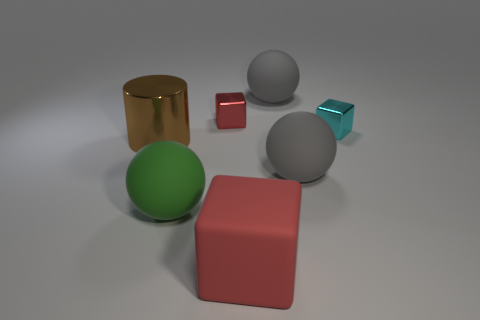Add 3 spheres. How many objects exist? 10 Subtract all purple balls. Subtract all red cylinders. How many balls are left? 3 Subtract all spheres. How many objects are left? 4 Add 3 small objects. How many small objects exist? 5 Subtract 1 green balls. How many objects are left? 6 Subtract all metal cylinders. Subtract all cyan objects. How many objects are left? 5 Add 2 tiny red metallic objects. How many tiny red metallic objects are left? 3 